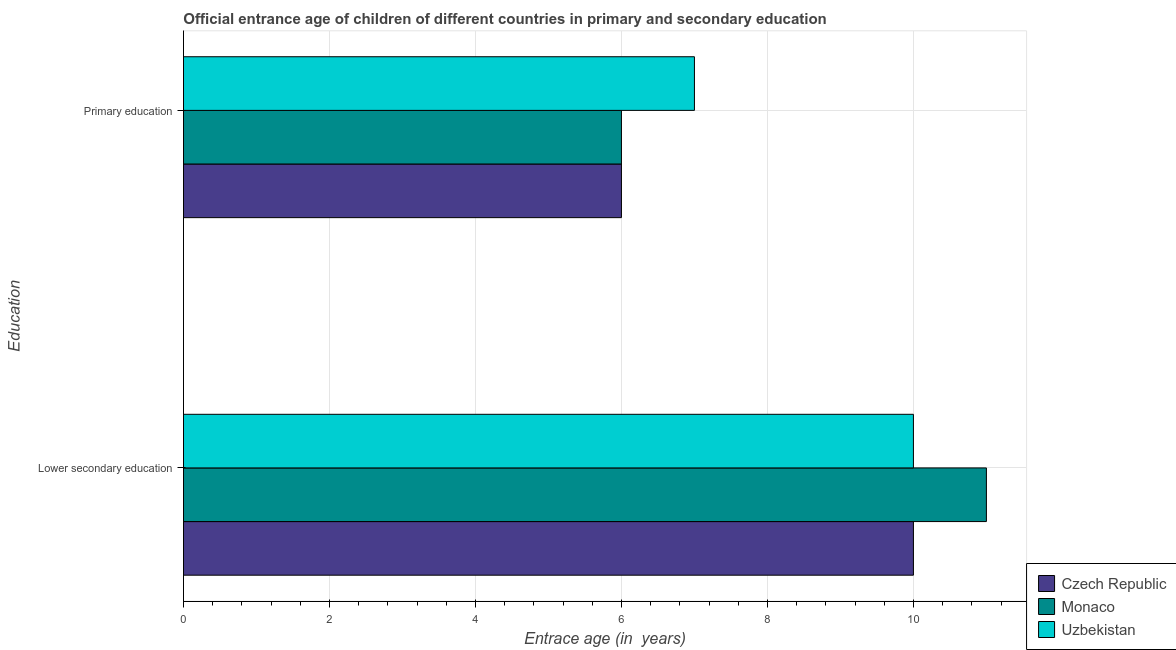How many bars are there on the 1st tick from the top?
Your answer should be compact. 3. What is the label of the 2nd group of bars from the top?
Offer a very short reply. Lower secondary education. What is the entrance age of children in lower secondary education in Monaco?
Make the answer very short. 11. Across all countries, what is the maximum entrance age of chiildren in primary education?
Make the answer very short. 7. In which country was the entrance age of chiildren in primary education maximum?
Offer a very short reply. Uzbekistan. In which country was the entrance age of children in lower secondary education minimum?
Make the answer very short. Czech Republic. What is the total entrance age of chiildren in primary education in the graph?
Your answer should be very brief. 19. What is the difference between the entrance age of chiildren in primary education in Uzbekistan and that in Monaco?
Your response must be concise. 1. What is the difference between the entrance age of chiildren in primary education in Czech Republic and the entrance age of children in lower secondary education in Monaco?
Provide a short and direct response. -5. What is the average entrance age of chiildren in primary education per country?
Make the answer very short. 6.33. What is the difference between the entrance age of chiildren in primary education and entrance age of children in lower secondary education in Czech Republic?
Make the answer very short. -4. In how many countries, is the entrance age of chiildren in primary education greater than 6.4 years?
Keep it short and to the point. 1. What is the ratio of the entrance age of chiildren in primary education in Uzbekistan to that in Czech Republic?
Offer a terse response. 1.17. Is the entrance age of chiildren in primary education in Uzbekistan less than that in Monaco?
Ensure brevity in your answer.  No. In how many countries, is the entrance age of children in lower secondary education greater than the average entrance age of children in lower secondary education taken over all countries?
Ensure brevity in your answer.  1. What does the 2nd bar from the top in Primary education represents?
Offer a very short reply. Monaco. What does the 1st bar from the bottom in Primary education represents?
Offer a very short reply. Czech Republic. How many bars are there?
Your answer should be very brief. 6. Are all the bars in the graph horizontal?
Your answer should be very brief. Yes. How many countries are there in the graph?
Your response must be concise. 3. What is the difference between two consecutive major ticks on the X-axis?
Keep it short and to the point. 2. Does the graph contain grids?
Give a very brief answer. Yes. Where does the legend appear in the graph?
Provide a short and direct response. Bottom right. What is the title of the graph?
Your answer should be compact. Official entrance age of children of different countries in primary and secondary education. What is the label or title of the X-axis?
Keep it short and to the point. Entrace age (in  years). What is the label or title of the Y-axis?
Your answer should be very brief. Education. What is the Entrace age (in  years) in Czech Republic in Lower secondary education?
Your answer should be very brief. 10. What is the Entrace age (in  years) of Uzbekistan in Lower secondary education?
Your answer should be very brief. 10. What is the Entrace age (in  years) in Czech Republic in Primary education?
Keep it short and to the point. 6. What is the Entrace age (in  years) of Uzbekistan in Primary education?
Make the answer very short. 7. Across all Education, what is the maximum Entrace age (in  years) of Czech Republic?
Provide a short and direct response. 10. Across all Education, what is the minimum Entrace age (in  years) of Monaco?
Your answer should be very brief. 6. Across all Education, what is the minimum Entrace age (in  years) in Uzbekistan?
Make the answer very short. 7. What is the total Entrace age (in  years) of Czech Republic in the graph?
Give a very brief answer. 16. What is the difference between the Entrace age (in  years) of Monaco in Lower secondary education and that in Primary education?
Offer a very short reply. 5. What is the difference between the Entrace age (in  years) of Czech Republic in Lower secondary education and the Entrace age (in  years) of Monaco in Primary education?
Offer a very short reply. 4. What is the difference between the Entrace age (in  years) of Czech Republic in Lower secondary education and the Entrace age (in  years) of Uzbekistan in Primary education?
Keep it short and to the point. 3. What is the average Entrace age (in  years) in Czech Republic per Education?
Provide a short and direct response. 8. What is the difference between the Entrace age (in  years) in Monaco and Entrace age (in  years) in Uzbekistan in Primary education?
Offer a very short reply. -1. What is the ratio of the Entrace age (in  years) of Monaco in Lower secondary education to that in Primary education?
Your answer should be very brief. 1.83. What is the ratio of the Entrace age (in  years) of Uzbekistan in Lower secondary education to that in Primary education?
Your answer should be very brief. 1.43. What is the difference between the highest and the second highest Entrace age (in  years) of Monaco?
Your response must be concise. 5. What is the difference between the highest and the lowest Entrace age (in  years) of Czech Republic?
Your answer should be compact. 4. What is the difference between the highest and the lowest Entrace age (in  years) in Monaco?
Give a very brief answer. 5. 